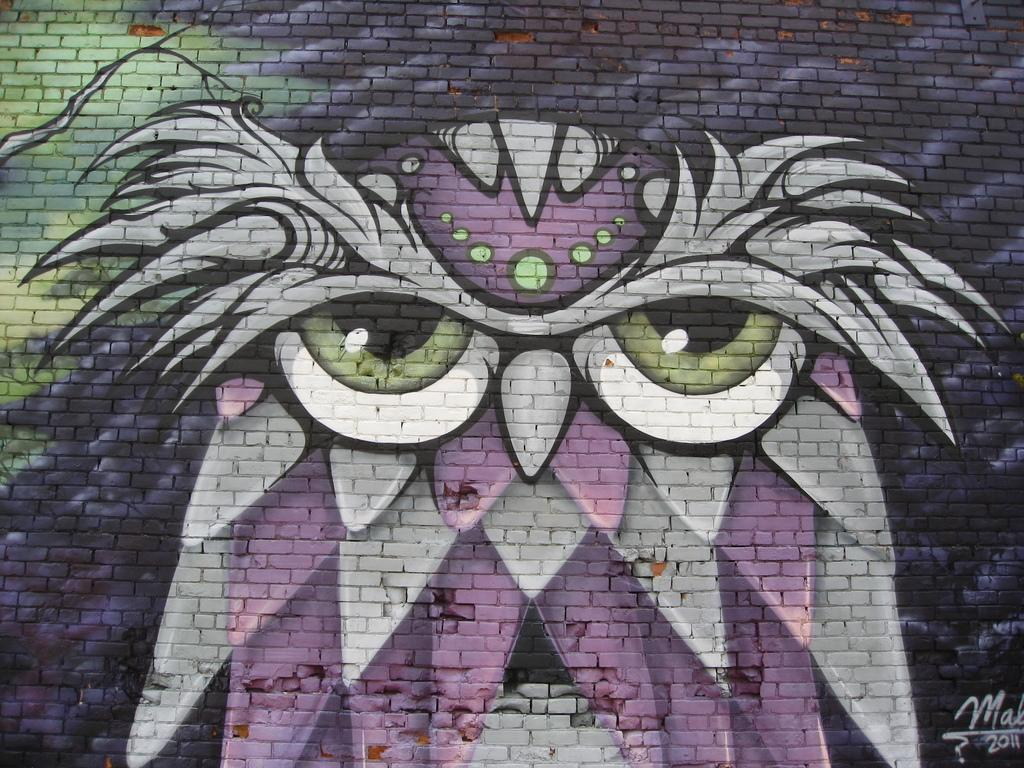What is present on the wall in the image? There is an art piece on the wall. Can you describe the art piece? The art piece is colorful. Are there any words or numbers on the art piece? Yes, there are words and numbers written on the art piece. What type of silver impulse can be seen driving a carriage in the image? There is no silver impulse or carriage present in the image; it features an art piece on a wall with words and numbers. 